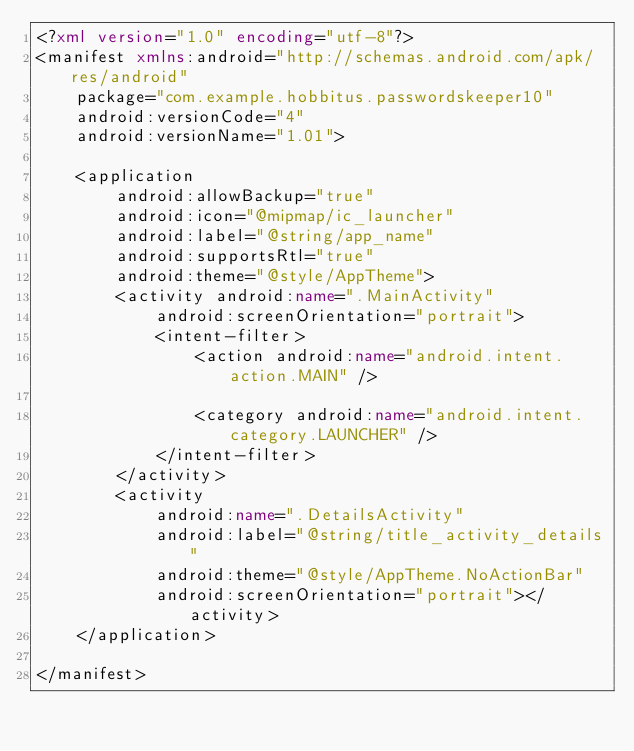<code> <loc_0><loc_0><loc_500><loc_500><_XML_><?xml version="1.0" encoding="utf-8"?>
<manifest xmlns:android="http://schemas.android.com/apk/res/android"
    package="com.example.hobbitus.passwordskeeper10"
    android:versionCode="4"
    android:versionName="1.01">

    <application
        android:allowBackup="true"
        android:icon="@mipmap/ic_launcher"
        android:label="@string/app_name"
        android:supportsRtl="true"
        android:theme="@style/AppTheme">
        <activity android:name=".MainActivity"
            android:screenOrientation="portrait">
            <intent-filter>
                <action android:name="android.intent.action.MAIN" />

                <category android:name="android.intent.category.LAUNCHER" />
            </intent-filter>
        </activity>
        <activity
            android:name=".DetailsActivity"
            android:label="@string/title_activity_details"
            android:theme="@style/AppTheme.NoActionBar"
            android:screenOrientation="portrait"></activity>
    </application>

</manifest></code> 